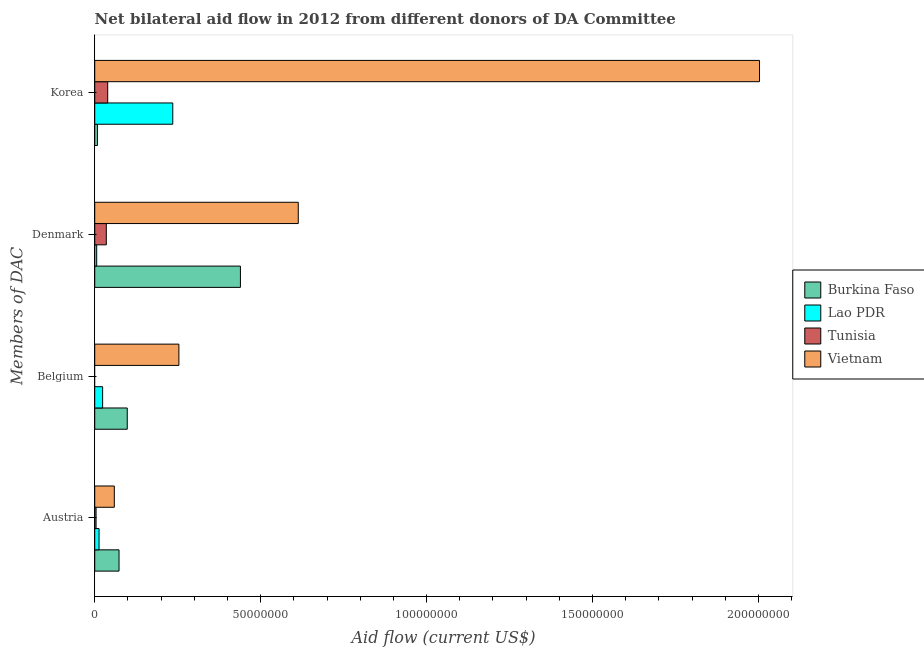How many different coloured bars are there?
Your answer should be compact. 4. How many groups of bars are there?
Your answer should be very brief. 4. How many bars are there on the 3rd tick from the top?
Provide a short and direct response. 3. How many bars are there on the 1st tick from the bottom?
Offer a very short reply. 4. What is the amount of aid given by austria in Burkina Faso?
Ensure brevity in your answer.  7.32e+06. Across all countries, what is the maximum amount of aid given by austria?
Offer a very short reply. 7.32e+06. Across all countries, what is the minimum amount of aid given by korea?
Your answer should be very brief. 8.10e+05. In which country was the amount of aid given by austria maximum?
Provide a succinct answer. Burkina Faso. What is the total amount of aid given by belgium in the graph?
Offer a very short reply. 3.75e+07. What is the difference between the amount of aid given by belgium in Vietnam and that in Burkina Faso?
Your response must be concise. 1.56e+07. What is the difference between the amount of aid given by austria in Lao PDR and the amount of aid given by belgium in Vietnam?
Your response must be concise. -2.41e+07. What is the average amount of aid given by korea per country?
Ensure brevity in your answer.  5.71e+07. What is the difference between the amount of aid given by denmark and amount of aid given by korea in Burkina Faso?
Give a very brief answer. 4.31e+07. In how many countries, is the amount of aid given by belgium greater than 140000000 US$?
Make the answer very short. 0. What is the ratio of the amount of aid given by austria in Burkina Faso to that in Tunisia?
Provide a succinct answer. 18.3. Is the amount of aid given by korea in Burkina Faso less than that in Tunisia?
Provide a short and direct response. Yes. Is the difference between the amount of aid given by korea in Vietnam and Lao PDR greater than the difference between the amount of aid given by denmark in Vietnam and Lao PDR?
Give a very brief answer. Yes. What is the difference between the highest and the second highest amount of aid given by austria?
Make the answer very short. 1.42e+06. What is the difference between the highest and the lowest amount of aid given by korea?
Make the answer very short. 2.00e+08. Is the sum of the amount of aid given by austria in Lao PDR and Vietnam greater than the maximum amount of aid given by korea across all countries?
Your answer should be compact. No. Is it the case that in every country, the sum of the amount of aid given by korea and amount of aid given by austria is greater than the sum of amount of aid given by belgium and amount of aid given by denmark?
Offer a very short reply. No. How many bars are there?
Offer a very short reply. 15. Are all the bars in the graph horizontal?
Your response must be concise. Yes. How many countries are there in the graph?
Offer a very short reply. 4. What is the difference between two consecutive major ticks on the X-axis?
Your answer should be compact. 5.00e+07. Does the graph contain any zero values?
Make the answer very short. Yes. Where does the legend appear in the graph?
Give a very brief answer. Center right. What is the title of the graph?
Provide a succinct answer. Net bilateral aid flow in 2012 from different donors of DA Committee. What is the label or title of the Y-axis?
Your response must be concise. Members of DAC. What is the Aid flow (current US$) of Burkina Faso in Austria?
Your answer should be very brief. 7.32e+06. What is the Aid flow (current US$) in Lao PDR in Austria?
Provide a succinct answer. 1.30e+06. What is the Aid flow (current US$) in Vietnam in Austria?
Offer a very short reply. 5.90e+06. What is the Aid flow (current US$) in Burkina Faso in Belgium?
Give a very brief answer. 9.80e+06. What is the Aid flow (current US$) of Lao PDR in Belgium?
Provide a short and direct response. 2.38e+06. What is the Aid flow (current US$) in Tunisia in Belgium?
Provide a succinct answer. 0. What is the Aid flow (current US$) of Vietnam in Belgium?
Give a very brief answer. 2.54e+07. What is the Aid flow (current US$) of Burkina Faso in Denmark?
Provide a short and direct response. 4.39e+07. What is the Aid flow (current US$) of Lao PDR in Denmark?
Your answer should be very brief. 5.90e+05. What is the Aid flow (current US$) in Tunisia in Denmark?
Make the answer very short. 3.49e+06. What is the Aid flow (current US$) in Vietnam in Denmark?
Provide a succinct answer. 6.13e+07. What is the Aid flow (current US$) of Burkina Faso in Korea?
Give a very brief answer. 8.10e+05. What is the Aid flow (current US$) of Lao PDR in Korea?
Your answer should be very brief. 2.35e+07. What is the Aid flow (current US$) of Tunisia in Korea?
Make the answer very short. 3.91e+06. What is the Aid flow (current US$) of Vietnam in Korea?
Your response must be concise. 2.00e+08. Across all Members of DAC, what is the maximum Aid flow (current US$) of Burkina Faso?
Your answer should be compact. 4.39e+07. Across all Members of DAC, what is the maximum Aid flow (current US$) of Lao PDR?
Provide a short and direct response. 2.35e+07. Across all Members of DAC, what is the maximum Aid flow (current US$) in Tunisia?
Give a very brief answer. 3.91e+06. Across all Members of DAC, what is the maximum Aid flow (current US$) in Vietnam?
Keep it short and to the point. 2.00e+08. Across all Members of DAC, what is the minimum Aid flow (current US$) of Burkina Faso?
Provide a short and direct response. 8.10e+05. Across all Members of DAC, what is the minimum Aid flow (current US$) of Lao PDR?
Make the answer very short. 5.90e+05. Across all Members of DAC, what is the minimum Aid flow (current US$) in Vietnam?
Your response must be concise. 5.90e+06. What is the total Aid flow (current US$) of Burkina Faso in the graph?
Provide a succinct answer. 6.18e+07. What is the total Aid flow (current US$) of Lao PDR in the graph?
Offer a terse response. 2.78e+07. What is the total Aid flow (current US$) of Tunisia in the graph?
Give a very brief answer. 7.80e+06. What is the total Aid flow (current US$) in Vietnam in the graph?
Your answer should be very brief. 2.93e+08. What is the difference between the Aid flow (current US$) of Burkina Faso in Austria and that in Belgium?
Offer a very short reply. -2.48e+06. What is the difference between the Aid flow (current US$) of Lao PDR in Austria and that in Belgium?
Give a very brief answer. -1.08e+06. What is the difference between the Aid flow (current US$) in Vietnam in Austria and that in Belgium?
Make the answer very short. -1.95e+07. What is the difference between the Aid flow (current US$) in Burkina Faso in Austria and that in Denmark?
Offer a very short reply. -3.66e+07. What is the difference between the Aid flow (current US$) of Lao PDR in Austria and that in Denmark?
Offer a terse response. 7.10e+05. What is the difference between the Aid flow (current US$) of Tunisia in Austria and that in Denmark?
Keep it short and to the point. -3.09e+06. What is the difference between the Aid flow (current US$) in Vietnam in Austria and that in Denmark?
Ensure brevity in your answer.  -5.54e+07. What is the difference between the Aid flow (current US$) of Burkina Faso in Austria and that in Korea?
Your response must be concise. 6.51e+06. What is the difference between the Aid flow (current US$) of Lao PDR in Austria and that in Korea?
Provide a succinct answer. -2.22e+07. What is the difference between the Aid flow (current US$) in Tunisia in Austria and that in Korea?
Ensure brevity in your answer.  -3.51e+06. What is the difference between the Aid flow (current US$) in Vietnam in Austria and that in Korea?
Provide a succinct answer. -1.94e+08. What is the difference between the Aid flow (current US$) of Burkina Faso in Belgium and that in Denmark?
Provide a succinct answer. -3.41e+07. What is the difference between the Aid flow (current US$) in Lao PDR in Belgium and that in Denmark?
Your answer should be very brief. 1.79e+06. What is the difference between the Aid flow (current US$) in Vietnam in Belgium and that in Denmark?
Offer a terse response. -3.60e+07. What is the difference between the Aid flow (current US$) in Burkina Faso in Belgium and that in Korea?
Provide a succinct answer. 8.99e+06. What is the difference between the Aid flow (current US$) of Lao PDR in Belgium and that in Korea?
Your answer should be very brief. -2.11e+07. What is the difference between the Aid flow (current US$) in Vietnam in Belgium and that in Korea?
Make the answer very short. -1.75e+08. What is the difference between the Aid flow (current US$) of Burkina Faso in Denmark and that in Korea?
Offer a very short reply. 4.31e+07. What is the difference between the Aid flow (current US$) in Lao PDR in Denmark and that in Korea?
Your answer should be compact. -2.29e+07. What is the difference between the Aid flow (current US$) of Tunisia in Denmark and that in Korea?
Your answer should be compact. -4.20e+05. What is the difference between the Aid flow (current US$) in Vietnam in Denmark and that in Korea?
Offer a terse response. -1.39e+08. What is the difference between the Aid flow (current US$) of Burkina Faso in Austria and the Aid flow (current US$) of Lao PDR in Belgium?
Offer a very short reply. 4.94e+06. What is the difference between the Aid flow (current US$) in Burkina Faso in Austria and the Aid flow (current US$) in Vietnam in Belgium?
Ensure brevity in your answer.  -1.80e+07. What is the difference between the Aid flow (current US$) in Lao PDR in Austria and the Aid flow (current US$) in Vietnam in Belgium?
Ensure brevity in your answer.  -2.41e+07. What is the difference between the Aid flow (current US$) in Tunisia in Austria and the Aid flow (current US$) in Vietnam in Belgium?
Keep it short and to the point. -2.50e+07. What is the difference between the Aid flow (current US$) in Burkina Faso in Austria and the Aid flow (current US$) in Lao PDR in Denmark?
Provide a succinct answer. 6.73e+06. What is the difference between the Aid flow (current US$) in Burkina Faso in Austria and the Aid flow (current US$) in Tunisia in Denmark?
Provide a short and direct response. 3.83e+06. What is the difference between the Aid flow (current US$) of Burkina Faso in Austria and the Aid flow (current US$) of Vietnam in Denmark?
Make the answer very short. -5.40e+07. What is the difference between the Aid flow (current US$) of Lao PDR in Austria and the Aid flow (current US$) of Tunisia in Denmark?
Ensure brevity in your answer.  -2.19e+06. What is the difference between the Aid flow (current US$) of Lao PDR in Austria and the Aid flow (current US$) of Vietnam in Denmark?
Keep it short and to the point. -6.00e+07. What is the difference between the Aid flow (current US$) in Tunisia in Austria and the Aid flow (current US$) in Vietnam in Denmark?
Your answer should be very brief. -6.09e+07. What is the difference between the Aid flow (current US$) in Burkina Faso in Austria and the Aid flow (current US$) in Lao PDR in Korea?
Provide a succinct answer. -1.62e+07. What is the difference between the Aid flow (current US$) of Burkina Faso in Austria and the Aid flow (current US$) of Tunisia in Korea?
Offer a terse response. 3.41e+06. What is the difference between the Aid flow (current US$) in Burkina Faso in Austria and the Aid flow (current US$) in Vietnam in Korea?
Provide a short and direct response. -1.93e+08. What is the difference between the Aid flow (current US$) in Lao PDR in Austria and the Aid flow (current US$) in Tunisia in Korea?
Provide a short and direct response. -2.61e+06. What is the difference between the Aid flow (current US$) of Lao PDR in Austria and the Aid flow (current US$) of Vietnam in Korea?
Offer a very short reply. -1.99e+08. What is the difference between the Aid flow (current US$) in Tunisia in Austria and the Aid flow (current US$) in Vietnam in Korea?
Provide a short and direct response. -2.00e+08. What is the difference between the Aid flow (current US$) of Burkina Faso in Belgium and the Aid flow (current US$) of Lao PDR in Denmark?
Provide a short and direct response. 9.21e+06. What is the difference between the Aid flow (current US$) of Burkina Faso in Belgium and the Aid flow (current US$) of Tunisia in Denmark?
Your answer should be compact. 6.31e+06. What is the difference between the Aid flow (current US$) of Burkina Faso in Belgium and the Aid flow (current US$) of Vietnam in Denmark?
Ensure brevity in your answer.  -5.15e+07. What is the difference between the Aid flow (current US$) in Lao PDR in Belgium and the Aid flow (current US$) in Tunisia in Denmark?
Your response must be concise. -1.11e+06. What is the difference between the Aid flow (current US$) of Lao PDR in Belgium and the Aid flow (current US$) of Vietnam in Denmark?
Make the answer very short. -5.90e+07. What is the difference between the Aid flow (current US$) in Burkina Faso in Belgium and the Aid flow (current US$) in Lao PDR in Korea?
Offer a very short reply. -1.37e+07. What is the difference between the Aid flow (current US$) in Burkina Faso in Belgium and the Aid flow (current US$) in Tunisia in Korea?
Offer a very short reply. 5.89e+06. What is the difference between the Aid flow (current US$) in Burkina Faso in Belgium and the Aid flow (current US$) in Vietnam in Korea?
Offer a terse response. -1.91e+08. What is the difference between the Aid flow (current US$) of Lao PDR in Belgium and the Aid flow (current US$) of Tunisia in Korea?
Offer a very short reply. -1.53e+06. What is the difference between the Aid flow (current US$) in Lao PDR in Belgium and the Aid flow (current US$) in Vietnam in Korea?
Your answer should be very brief. -1.98e+08. What is the difference between the Aid flow (current US$) of Burkina Faso in Denmark and the Aid flow (current US$) of Lao PDR in Korea?
Provide a succinct answer. 2.04e+07. What is the difference between the Aid flow (current US$) in Burkina Faso in Denmark and the Aid flow (current US$) in Tunisia in Korea?
Ensure brevity in your answer.  4.00e+07. What is the difference between the Aid flow (current US$) in Burkina Faso in Denmark and the Aid flow (current US$) in Vietnam in Korea?
Your answer should be very brief. -1.56e+08. What is the difference between the Aid flow (current US$) in Lao PDR in Denmark and the Aid flow (current US$) in Tunisia in Korea?
Keep it short and to the point. -3.32e+06. What is the difference between the Aid flow (current US$) of Lao PDR in Denmark and the Aid flow (current US$) of Vietnam in Korea?
Your answer should be very brief. -2.00e+08. What is the difference between the Aid flow (current US$) of Tunisia in Denmark and the Aid flow (current US$) of Vietnam in Korea?
Give a very brief answer. -1.97e+08. What is the average Aid flow (current US$) of Burkina Faso per Members of DAC?
Provide a short and direct response. 1.55e+07. What is the average Aid flow (current US$) in Lao PDR per Members of DAC?
Offer a very short reply. 6.95e+06. What is the average Aid flow (current US$) in Tunisia per Members of DAC?
Your response must be concise. 1.95e+06. What is the average Aid flow (current US$) in Vietnam per Members of DAC?
Offer a terse response. 7.32e+07. What is the difference between the Aid flow (current US$) of Burkina Faso and Aid flow (current US$) of Lao PDR in Austria?
Provide a succinct answer. 6.02e+06. What is the difference between the Aid flow (current US$) in Burkina Faso and Aid flow (current US$) in Tunisia in Austria?
Offer a very short reply. 6.92e+06. What is the difference between the Aid flow (current US$) in Burkina Faso and Aid flow (current US$) in Vietnam in Austria?
Give a very brief answer. 1.42e+06. What is the difference between the Aid flow (current US$) of Lao PDR and Aid flow (current US$) of Tunisia in Austria?
Provide a short and direct response. 9.00e+05. What is the difference between the Aid flow (current US$) of Lao PDR and Aid flow (current US$) of Vietnam in Austria?
Keep it short and to the point. -4.60e+06. What is the difference between the Aid flow (current US$) of Tunisia and Aid flow (current US$) of Vietnam in Austria?
Provide a short and direct response. -5.50e+06. What is the difference between the Aid flow (current US$) of Burkina Faso and Aid flow (current US$) of Lao PDR in Belgium?
Offer a terse response. 7.42e+06. What is the difference between the Aid flow (current US$) in Burkina Faso and Aid flow (current US$) in Vietnam in Belgium?
Ensure brevity in your answer.  -1.56e+07. What is the difference between the Aid flow (current US$) in Lao PDR and Aid flow (current US$) in Vietnam in Belgium?
Ensure brevity in your answer.  -2.30e+07. What is the difference between the Aid flow (current US$) in Burkina Faso and Aid flow (current US$) in Lao PDR in Denmark?
Ensure brevity in your answer.  4.33e+07. What is the difference between the Aid flow (current US$) in Burkina Faso and Aid flow (current US$) in Tunisia in Denmark?
Offer a very short reply. 4.04e+07. What is the difference between the Aid flow (current US$) in Burkina Faso and Aid flow (current US$) in Vietnam in Denmark?
Your answer should be very brief. -1.74e+07. What is the difference between the Aid flow (current US$) in Lao PDR and Aid flow (current US$) in Tunisia in Denmark?
Provide a succinct answer. -2.90e+06. What is the difference between the Aid flow (current US$) of Lao PDR and Aid flow (current US$) of Vietnam in Denmark?
Offer a very short reply. -6.07e+07. What is the difference between the Aid flow (current US$) in Tunisia and Aid flow (current US$) in Vietnam in Denmark?
Give a very brief answer. -5.78e+07. What is the difference between the Aid flow (current US$) of Burkina Faso and Aid flow (current US$) of Lao PDR in Korea?
Keep it short and to the point. -2.27e+07. What is the difference between the Aid flow (current US$) of Burkina Faso and Aid flow (current US$) of Tunisia in Korea?
Provide a short and direct response. -3.10e+06. What is the difference between the Aid flow (current US$) in Burkina Faso and Aid flow (current US$) in Vietnam in Korea?
Your answer should be compact. -2.00e+08. What is the difference between the Aid flow (current US$) in Lao PDR and Aid flow (current US$) in Tunisia in Korea?
Your answer should be compact. 1.96e+07. What is the difference between the Aid flow (current US$) in Lao PDR and Aid flow (current US$) in Vietnam in Korea?
Provide a short and direct response. -1.77e+08. What is the difference between the Aid flow (current US$) of Tunisia and Aid flow (current US$) of Vietnam in Korea?
Your answer should be compact. -1.96e+08. What is the ratio of the Aid flow (current US$) in Burkina Faso in Austria to that in Belgium?
Give a very brief answer. 0.75. What is the ratio of the Aid flow (current US$) of Lao PDR in Austria to that in Belgium?
Provide a short and direct response. 0.55. What is the ratio of the Aid flow (current US$) in Vietnam in Austria to that in Belgium?
Your response must be concise. 0.23. What is the ratio of the Aid flow (current US$) of Burkina Faso in Austria to that in Denmark?
Your response must be concise. 0.17. What is the ratio of the Aid flow (current US$) in Lao PDR in Austria to that in Denmark?
Your response must be concise. 2.2. What is the ratio of the Aid flow (current US$) in Tunisia in Austria to that in Denmark?
Provide a succinct answer. 0.11. What is the ratio of the Aid flow (current US$) of Vietnam in Austria to that in Denmark?
Make the answer very short. 0.1. What is the ratio of the Aid flow (current US$) in Burkina Faso in Austria to that in Korea?
Provide a short and direct response. 9.04. What is the ratio of the Aid flow (current US$) in Lao PDR in Austria to that in Korea?
Your answer should be compact. 0.06. What is the ratio of the Aid flow (current US$) of Tunisia in Austria to that in Korea?
Offer a very short reply. 0.1. What is the ratio of the Aid flow (current US$) of Vietnam in Austria to that in Korea?
Provide a short and direct response. 0.03. What is the ratio of the Aid flow (current US$) of Burkina Faso in Belgium to that in Denmark?
Your answer should be compact. 0.22. What is the ratio of the Aid flow (current US$) of Lao PDR in Belgium to that in Denmark?
Keep it short and to the point. 4.03. What is the ratio of the Aid flow (current US$) in Vietnam in Belgium to that in Denmark?
Make the answer very short. 0.41. What is the ratio of the Aid flow (current US$) of Burkina Faso in Belgium to that in Korea?
Offer a terse response. 12.1. What is the ratio of the Aid flow (current US$) in Lao PDR in Belgium to that in Korea?
Make the answer very short. 0.1. What is the ratio of the Aid flow (current US$) in Vietnam in Belgium to that in Korea?
Provide a short and direct response. 0.13. What is the ratio of the Aid flow (current US$) of Burkina Faso in Denmark to that in Korea?
Make the answer very short. 54.2. What is the ratio of the Aid flow (current US$) in Lao PDR in Denmark to that in Korea?
Offer a very short reply. 0.03. What is the ratio of the Aid flow (current US$) in Tunisia in Denmark to that in Korea?
Provide a short and direct response. 0.89. What is the ratio of the Aid flow (current US$) of Vietnam in Denmark to that in Korea?
Provide a short and direct response. 0.31. What is the difference between the highest and the second highest Aid flow (current US$) of Burkina Faso?
Keep it short and to the point. 3.41e+07. What is the difference between the highest and the second highest Aid flow (current US$) in Lao PDR?
Make the answer very short. 2.11e+07. What is the difference between the highest and the second highest Aid flow (current US$) in Vietnam?
Make the answer very short. 1.39e+08. What is the difference between the highest and the lowest Aid flow (current US$) of Burkina Faso?
Your answer should be compact. 4.31e+07. What is the difference between the highest and the lowest Aid flow (current US$) of Lao PDR?
Provide a succinct answer. 2.29e+07. What is the difference between the highest and the lowest Aid flow (current US$) in Tunisia?
Provide a short and direct response. 3.91e+06. What is the difference between the highest and the lowest Aid flow (current US$) of Vietnam?
Ensure brevity in your answer.  1.94e+08. 